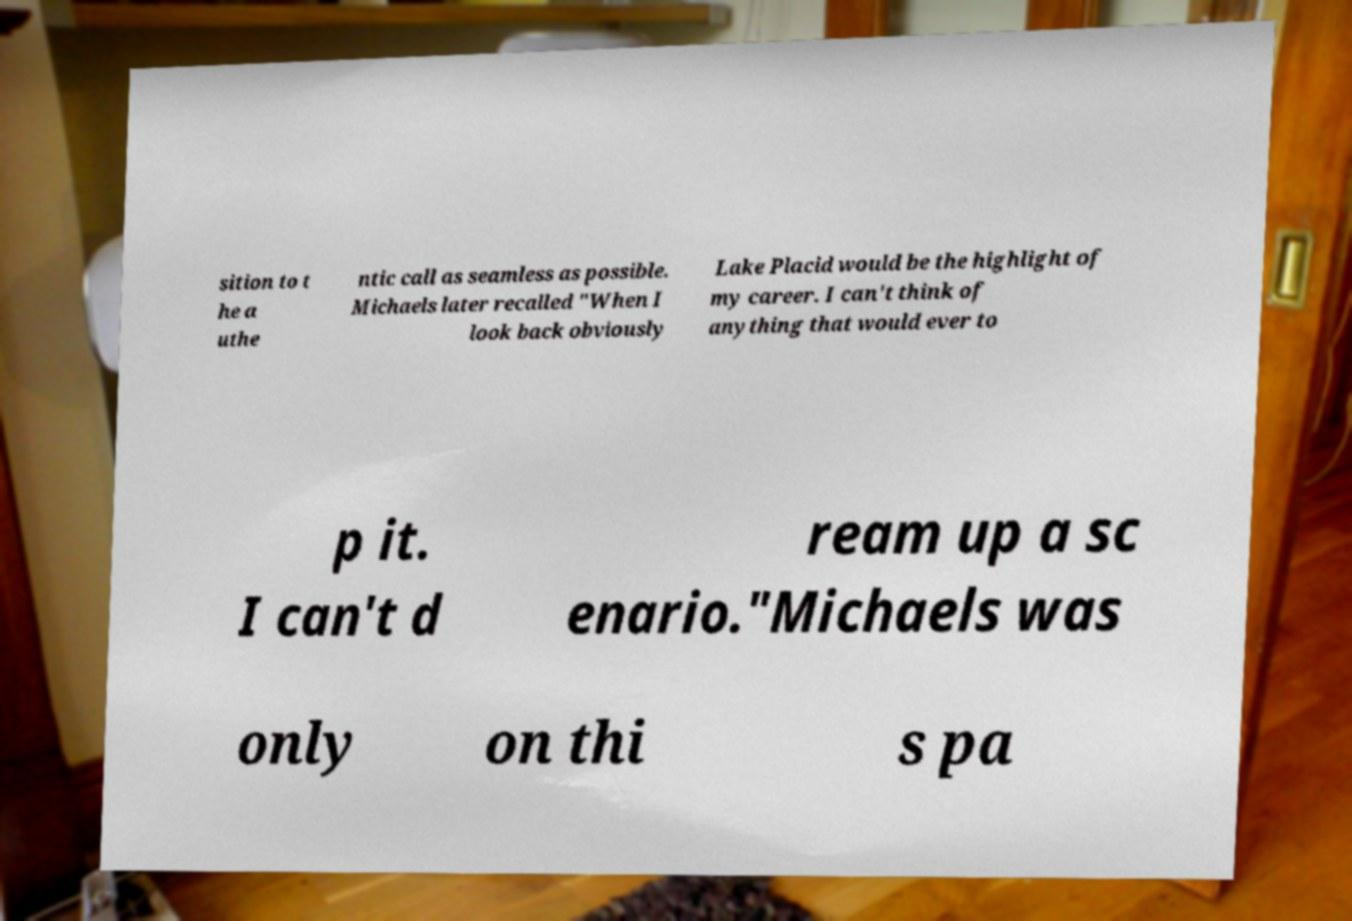There's text embedded in this image that I need extracted. Can you transcribe it verbatim? sition to t he a uthe ntic call as seamless as possible. Michaels later recalled "When I look back obviously Lake Placid would be the highlight of my career. I can't think of anything that would ever to p it. I can't d ream up a sc enario."Michaels was only on thi s pa 